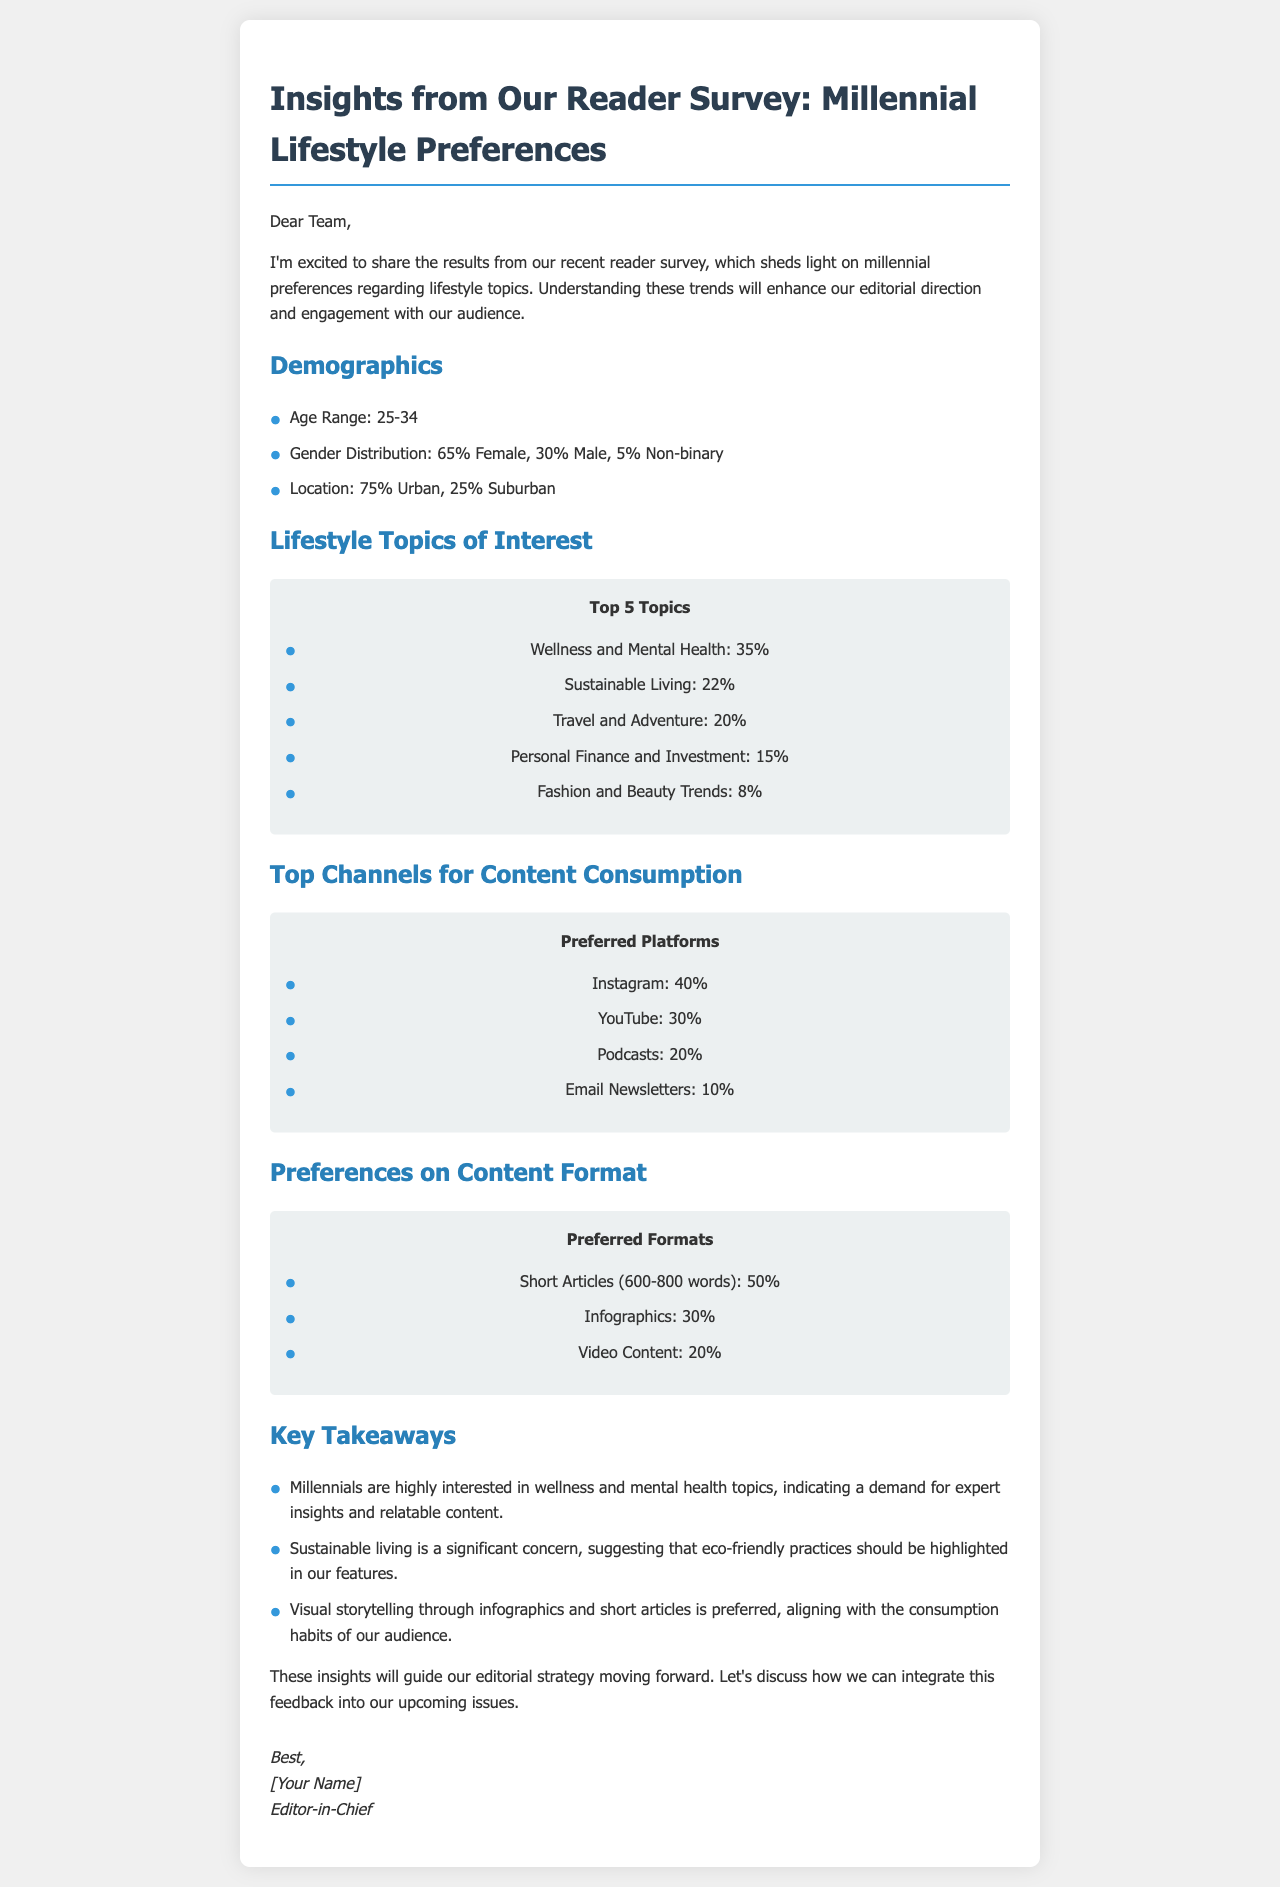What is the age range of surveyed readers? The age range of surveyed readers is stated in the demographics section of the document.
Answer: 25-34 What percentage of respondents are female? The percentage of female respondents is clearly indicated in the demographics section.
Answer: 65% What is the top interest topic among millennials? The lifestyle topics of interest section lists the top interests, with wellness being the highest.
Answer: Wellness and Mental Health Which platform do the most readers prefer for content? The preferred platforms section highlights the top channel, which has the highest percentage of preference.
Answer: Instagram What percentage of respondents prefer short articles? The preferred formats section provides the exact percentage of respondents who prefer short articles.
Answer: 50% How many lifestyle topics are mentioned in total? The number of lifestyle topics can be determined by counting the items listed in the respective section.
Answer: 5 What is the percentage of respondents interested in sustainable living? The relevant section mentions the exact percentage for sustainable living preferences.
Answer: 22% Which content format has the least preference? The preferred formats section indicates the format with the lowest percentage of preference among respondents.
Answer: Video Content What is the overall purpose of sharing this survey results document? The introductory paragraph of the document outlines the main goal of sharing these insights.
Answer: Enhance our editorial direction 